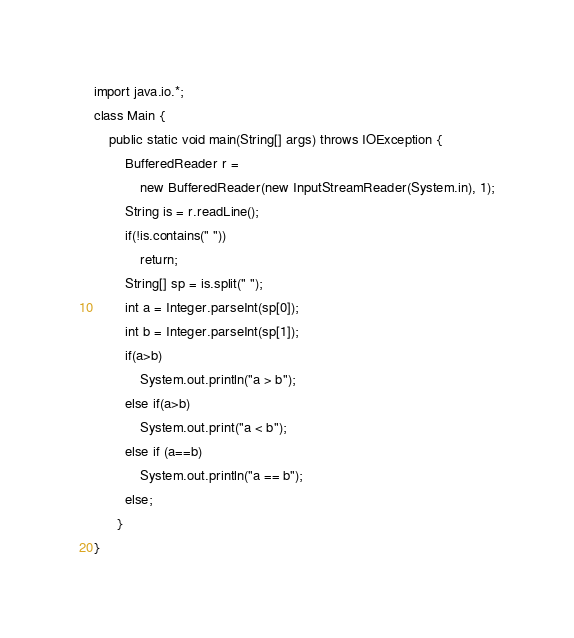Convert code to text. <code><loc_0><loc_0><loc_500><loc_500><_Java_>import java.io.*;
class Main {
    public static void main(String[] args) throws IOException {
        BufferedReader r =
            new BufferedReader(new InputStreamReader(System.in), 1);
        String is = r.readLine();
        if(!is.contains(" "))
            return;
        String[] sp = is.split(" ");
        int a = Integer.parseInt(sp[0]);
        int b = Integer.parseInt(sp[1]);
        if(a>b)
        	System.out.println("a > b");
        else if(a>b)
        	System.out.print("a < b");
        else if (a==b)
        	System.out.println("a == b");
        else;
      }
}</code> 